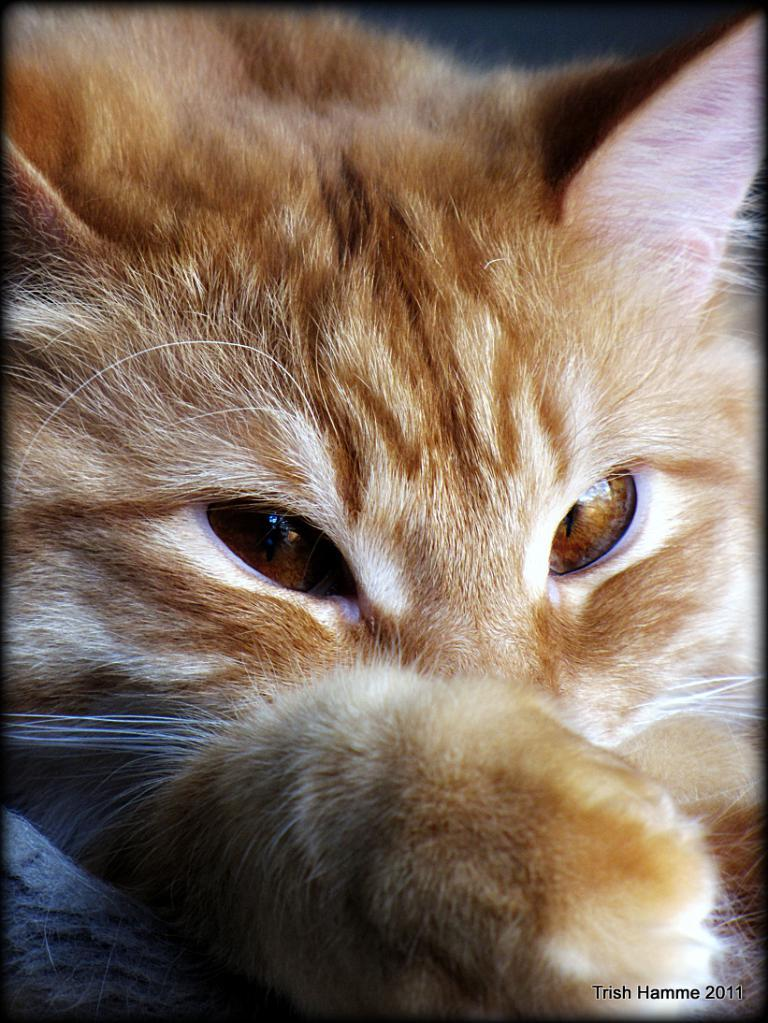What is the main subject of the image? There is a close-up picture of a cat in the image. Can you describe the appearance of the cat? The cat is pale brown and white in color. Is there any additional information or markings visible in the image? Yes, there is a watermark in the bottom right corner of the image. What type of plastic furniture can be seen in the background of the image? There is no plastic furniture visible in the image; it features a close-up picture of a cat with a watermark in the corner. 